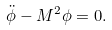<formula> <loc_0><loc_0><loc_500><loc_500>\ddot { \phi } - M ^ { 2 } \phi = 0 .</formula> 